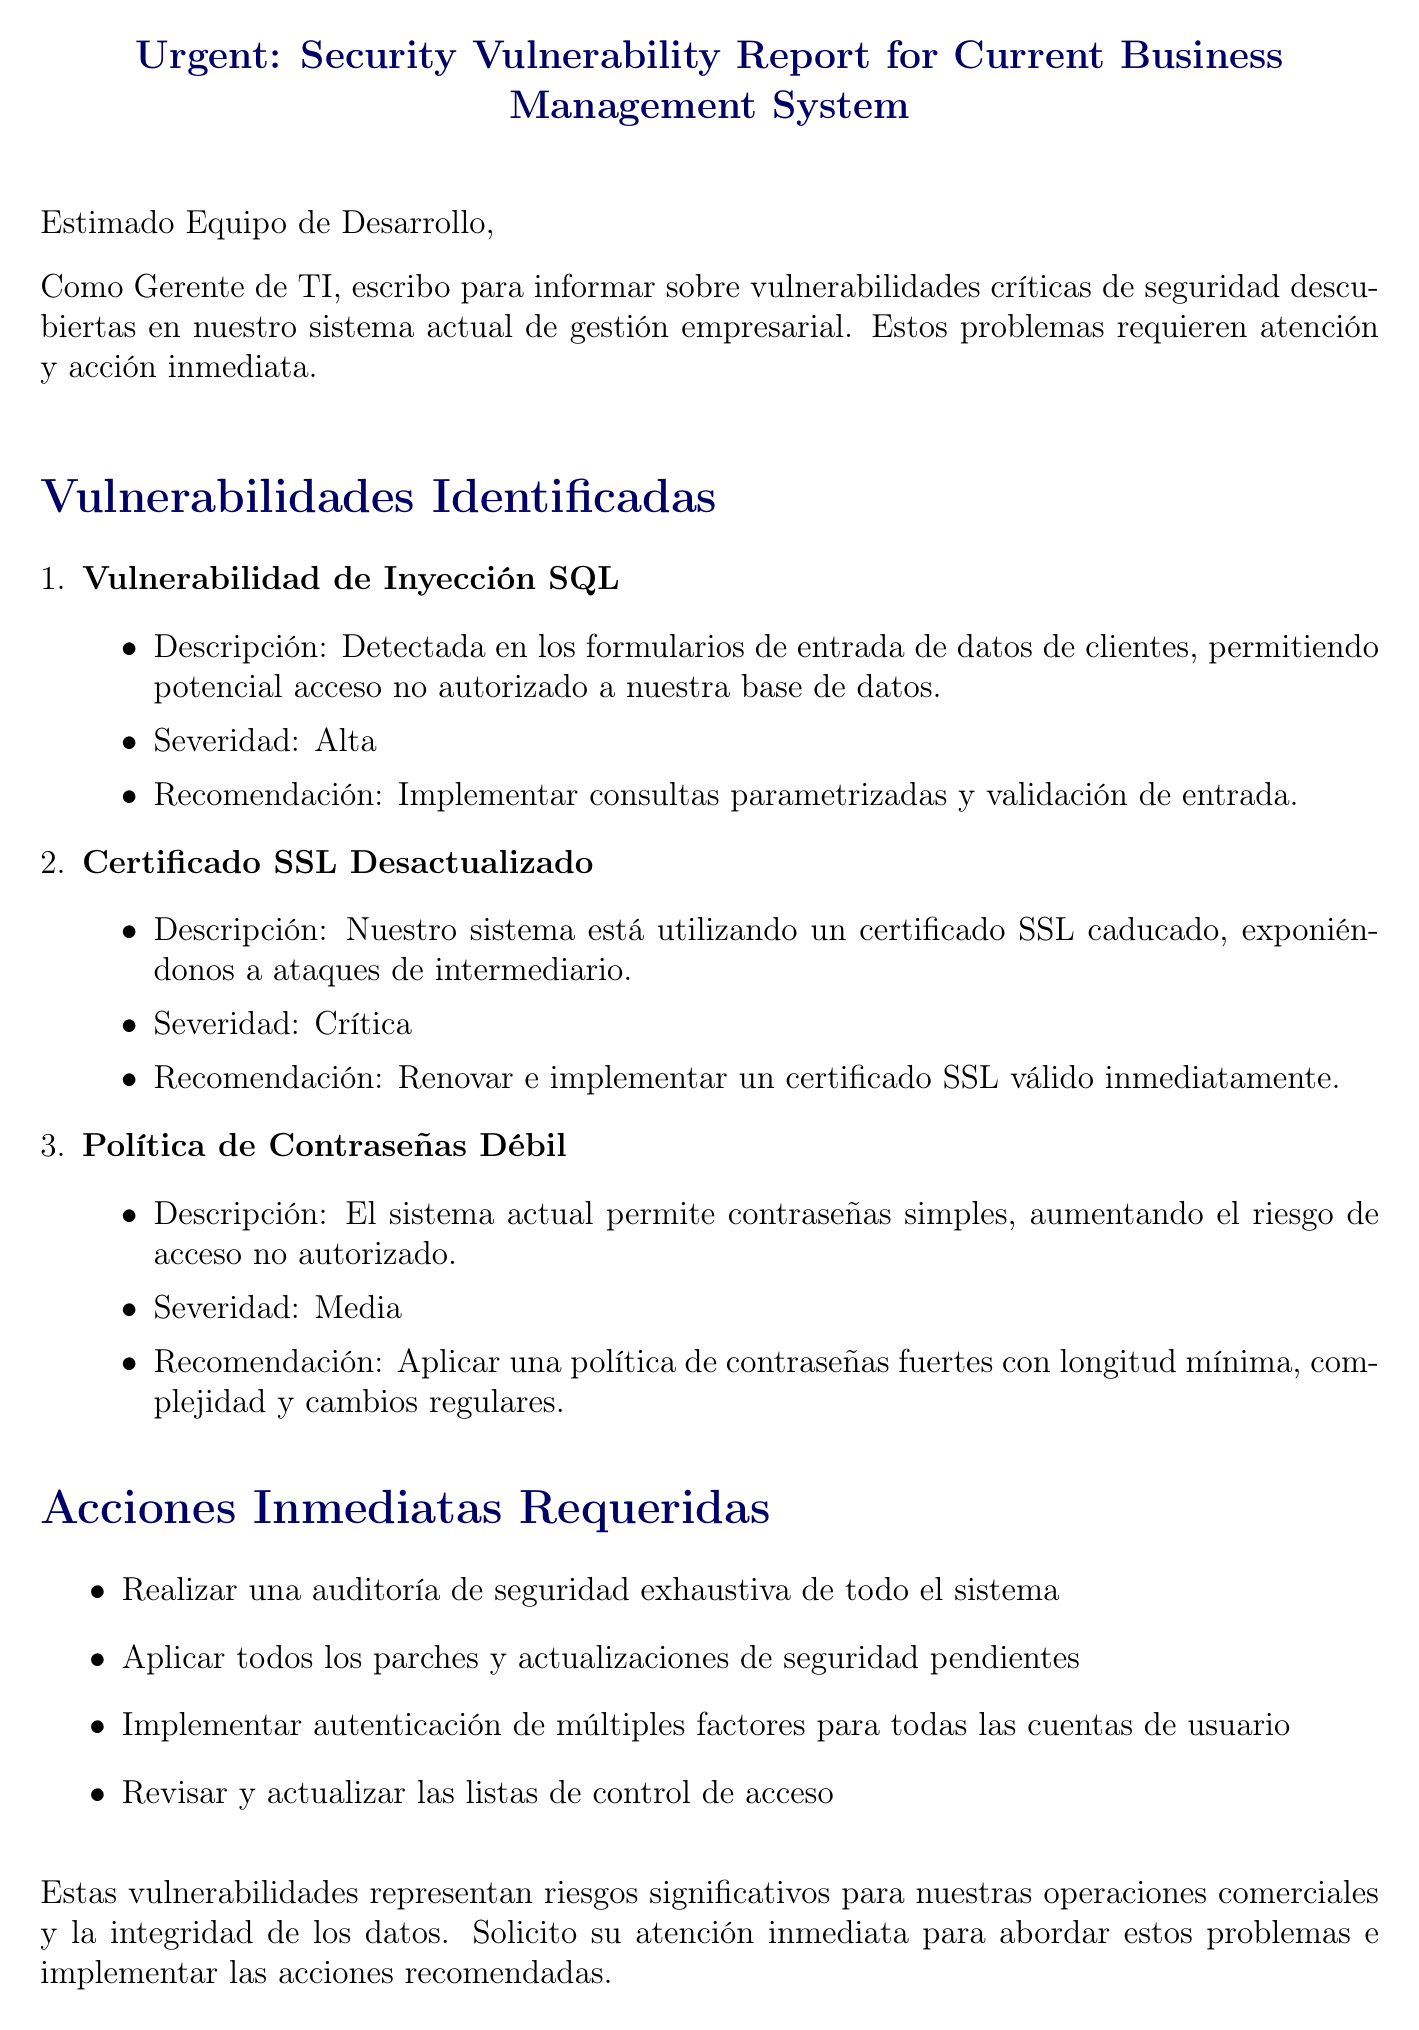What is the subject of the email? The subject of the email is outlined at the beginning of the document, stating the topic of the report.
Answer: Urgent: Security Vulnerability Report for Current Business Management System Who is the email addressed to? The greeting section specifies the recipient of the email.
Answer: Development Team What is the severity of the SQL Injection Vulnerability? The severity levels for each vulnerability are provided in the report under the vulnerabilities section.
Answer: High What action is recommended for the Outdated SSL Certificate? The recommendations for each vulnerability include suggested actions, particularly for the SSL issue.
Answer: Renew and implement a valid SSL certificate immediately How many vulnerabilities are identified in the report? The vulnerabilities are enumerated in the document, indicating the total count.
Answer: Three What is the immediate action required regarding the entire system? The actions are listed in the document, focusing on overall system security measures.
Answer: Conduct a thorough security audit of the entire system What is the consequence of having a Weak Password Policy? The description section elaborates on the risks associated with this specific vulnerability.
Answer: Increasing the risk of unauthorized access What is the time frame for providing an action plan? The conclusion provides a specific deadline for the response from the development team.
Answer: 24 hours 